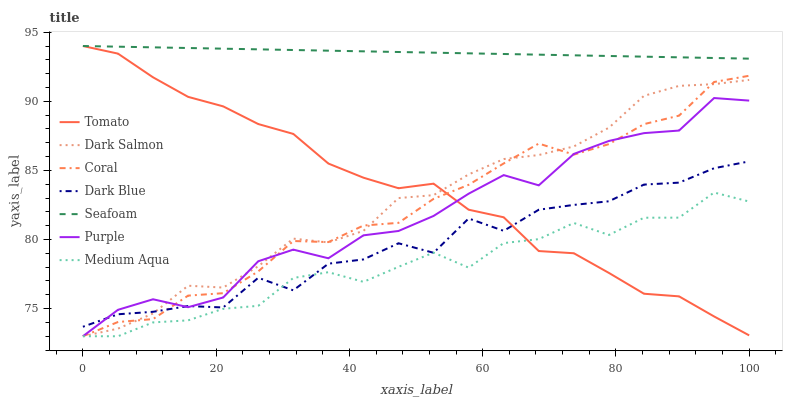Does Medium Aqua have the minimum area under the curve?
Answer yes or no. Yes. Does Seafoam have the maximum area under the curve?
Answer yes or no. Yes. Does Purple have the minimum area under the curve?
Answer yes or no. No. Does Purple have the maximum area under the curve?
Answer yes or no. No. Is Seafoam the smoothest?
Answer yes or no. Yes. Is Dark Blue the roughest?
Answer yes or no. Yes. Is Purple the smoothest?
Answer yes or no. No. Is Purple the roughest?
Answer yes or no. No. Does Purple have the lowest value?
Answer yes or no. Yes. Does Seafoam have the lowest value?
Answer yes or no. No. Does Seafoam have the highest value?
Answer yes or no. Yes. Does Purple have the highest value?
Answer yes or no. No. Is Purple less than Seafoam?
Answer yes or no. Yes. Is Seafoam greater than Medium Aqua?
Answer yes or no. Yes. Does Dark Blue intersect Purple?
Answer yes or no. Yes. Is Dark Blue less than Purple?
Answer yes or no. No. Is Dark Blue greater than Purple?
Answer yes or no. No. Does Purple intersect Seafoam?
Answer yes or no. No. 